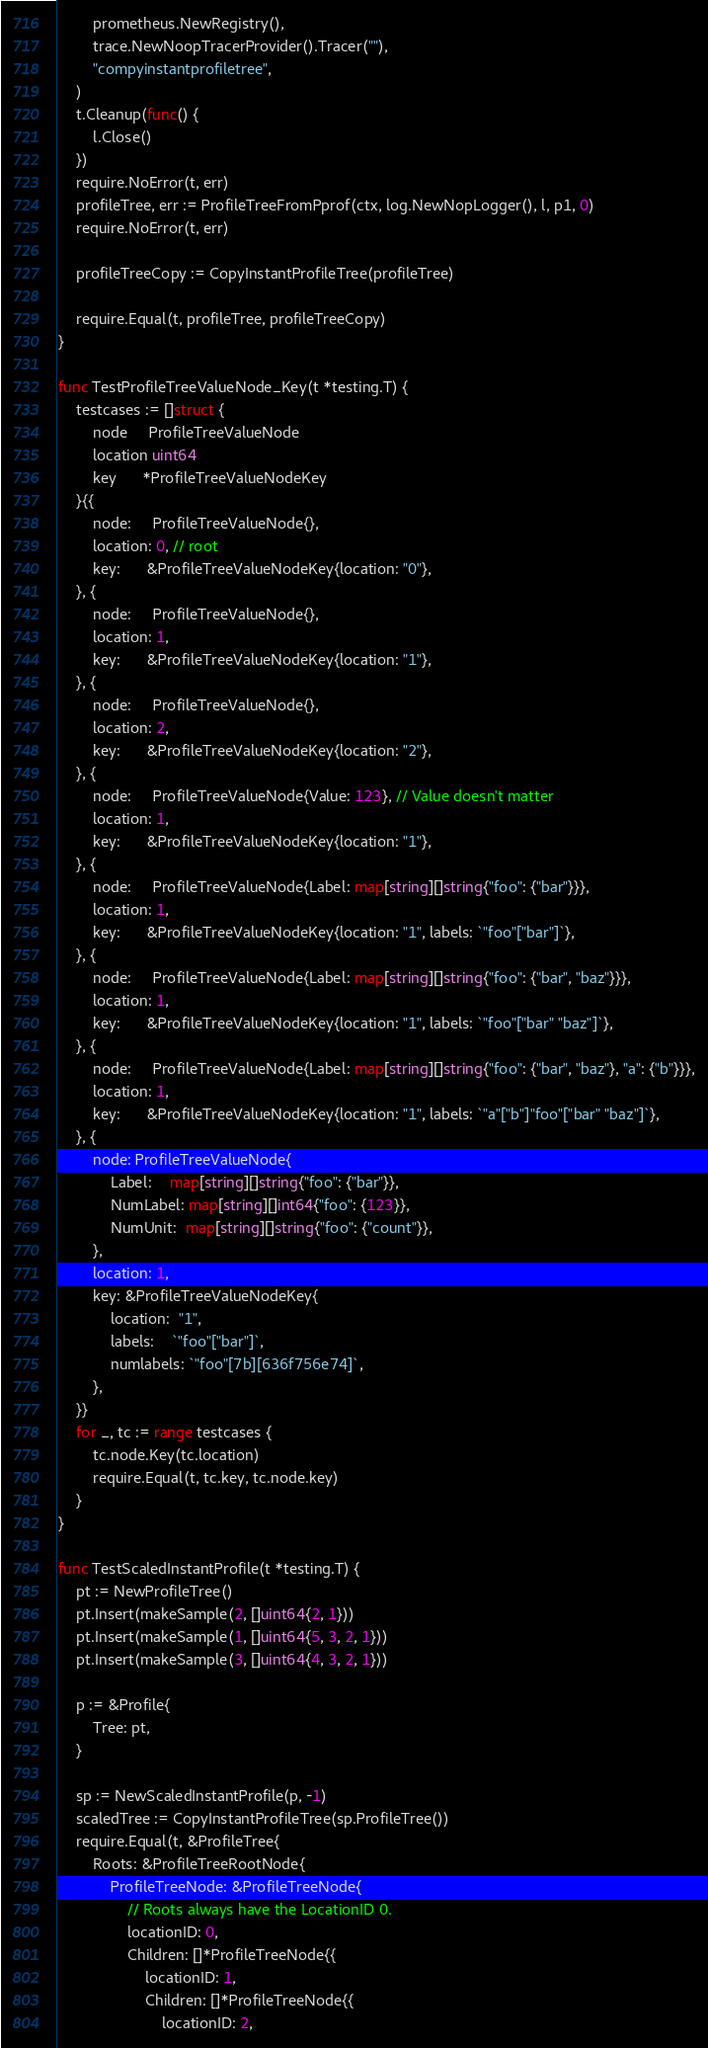Convert code to text. <code><loc_0><loc_0><loc_500><loc_500><_Go_>		prometheus.NewRegistry(),
		trace.NewNoopTracerProvider().Tracer(""),
		"compyinstantprofiletree",
	)
	t.Cleanup(func() {
		l.Close()
	})
	require.NoError(t, err)
	profileTree, err := ProfileTreeFromPprof(ctx, log.NewNopLogger(), l, p1, 0)
	require.NoError(t, err)

	profileTreeCopy := CopyInstantProfileTree(profileTree)

	require.Equal(t, profileTree, profileTreeCopy)
}

func TestProfileTreeValueNode_Key(t *testing.T) {
	testcases := []struct {
		node     ProfileTreeValueNode
		location uint64
		key      *ProfileTreeValueNodeKey
	}{{
		node:     ProfileTreeValueNode{},
		location: 0, // root
		key:      &ProfileTreeValueNodeKey{location: "0"},
	}, {
		node:     ProfileTreeValueNode{},
		location: 1,
		key:      &ProfileTreeValueNodeKey{location: "1"},
	}, {
		node:     ProfileTreeValueNode{},
		location: 2,
		key:      &ProfileTreeValueNodeKey{location: "2"},
	}, {
		node:     ProfileTreeValueNode{Value: 123}, // Value doesn't matter
		location: 1,
		key:      &ProfileTreeValueNodeKey{location: "1"},
	}, {
		node:     ProfileTreeValueNode{Label: map[string][]string{"foo": {"bar"}}},
		location: 1,
		key:      &ProfileTreeValueNodeKey{location: "1", labels: `"foo"["bar"]`},
	}, {
		node:     ProfileTreeValueNode{Label: map[string][]string{"foo": {"bar", "baz"}}},
		location: 1,
		key:      &ProfileTreeValueNodeKey{location: "1", labels: `"foo"["bar" "baz"]`},
	}, {
		node:     ProfileTreeValueNode{Label: map[string][]string{"foo": {"bar", "baz"}, "a": {"b"}}},
		location: 1,
		key:      &ProfileTreeValueNodeKey{location: "1", labels: `"a"["b"]"foo"["bar" "baz"]`},
	}, {
		node: ProfileTreeValueNode{
			Label:    map[string][]string{"foo": {"bar"}},
			NumLabel: map[string][]int64{"foo": {123}},
			NumUnit:  map[string][]string{"foo": {"count"}},
		},
		location: 1,
		key: &ProfileTreeValueNodeKey{
			location:  "1",
			labels:    `"foo"["bar"]`,
			numlabels: `"foo"[7b][636f756e74]`,
		},
	}}
	for _, tc := range testcases {
		tc.node.Key(tc.location)
		require.Equal(t, tc.key, tc.node.key)
	}
}

func TestScaledInstantProfile(t *testing.T) {
	pt := NewProfileTree()
	pt.Insert(makeSample(2, []uint64{2, 1}))
	pt.Insert(makeSample(1, []uint64{5, 3, 2, 1}))
	pt.Insert(makeSample(3, []uint64{4, 3, 2, 1}))

	p := &Profile{
		Tree: pt,
	}

	sp := NewScaledInstantProfile(p, -1)
	scaledTree := CopyInstantProfileTree(sp.ProfileTree())
	require.Equal(t, &ProfileTree{
		Roots: &ProfileTreeRootNode{
			ProfileTreeNode: &ProfileTreeNode{
				// Roots always have the LocationID 0.
				locationID: 0,
				Children: []*ProfileTreeNode{{
					locationID: 1,
					Children: []*ProfileTreeNode{{
						locationID: 2,</code> 